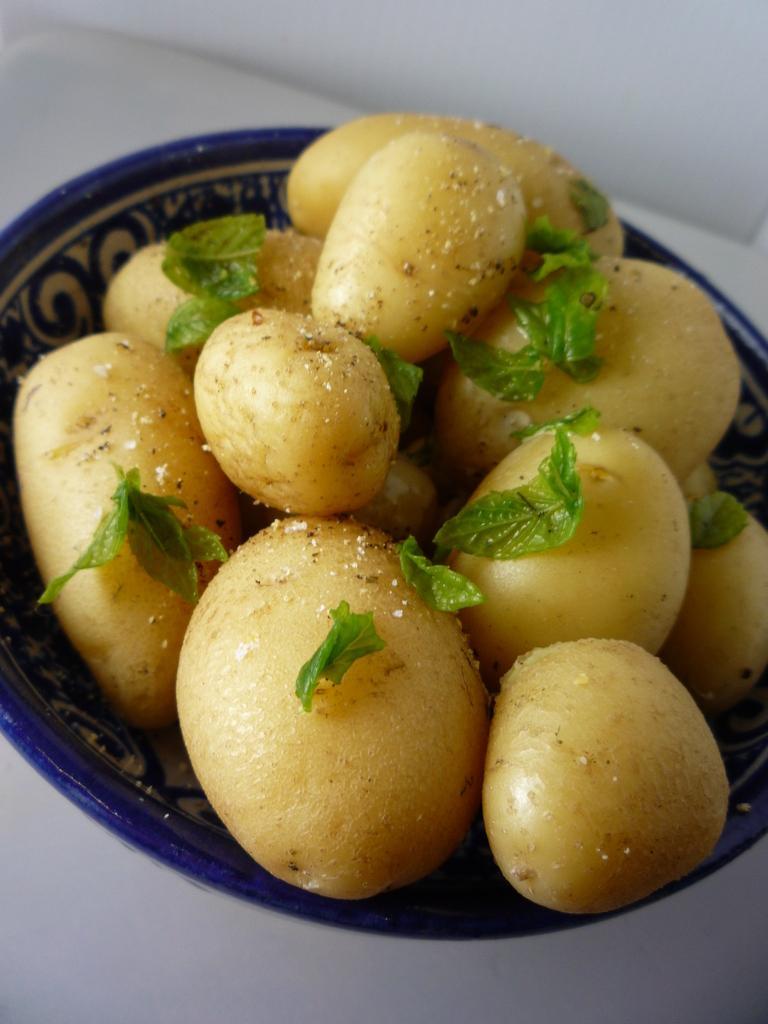Can you describe this image briefly? In this image we can see a bowl with some potatoes and leaves on the table. 